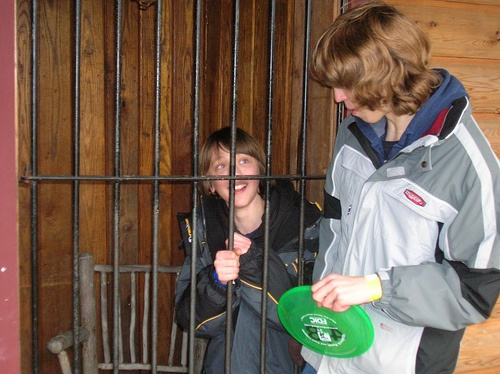Describe the objects in this image and their specific colors. I can see people in brown, lightgray, darkgray, gray, and black tones, people in brown, black, gray, lightpink, and maroon tones, chair in brown, gray, black, and maroon tones, and frisbee in brown, green, and lightgreen tones in this image. 